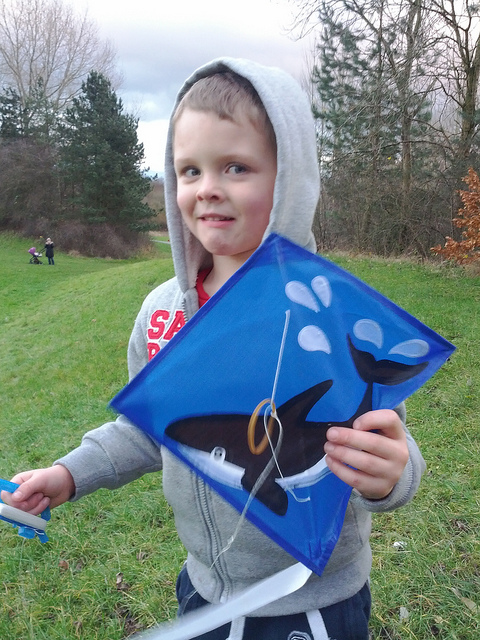Identify and read out the text in this image. SA 